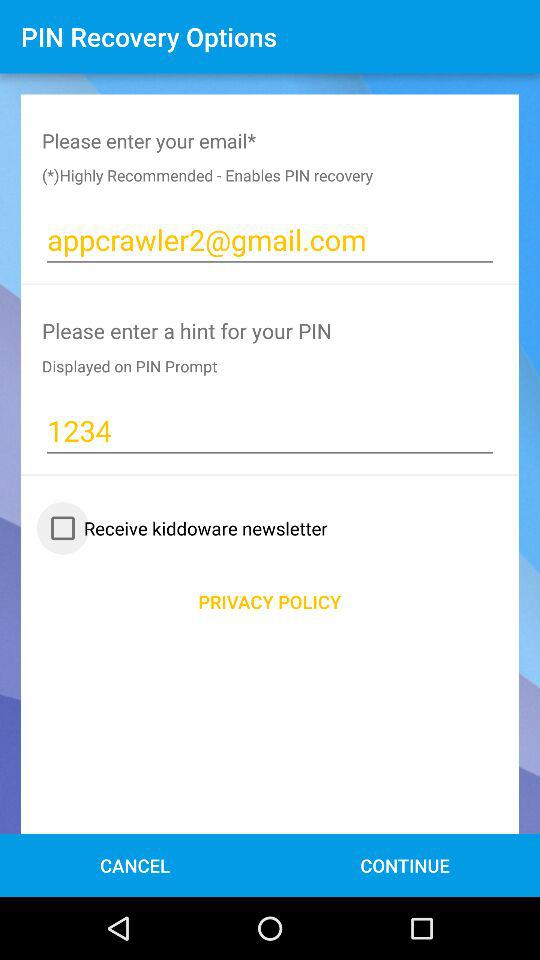How many text inputs are there that are not empty?
Answer the question using a single word or phrase. 2 